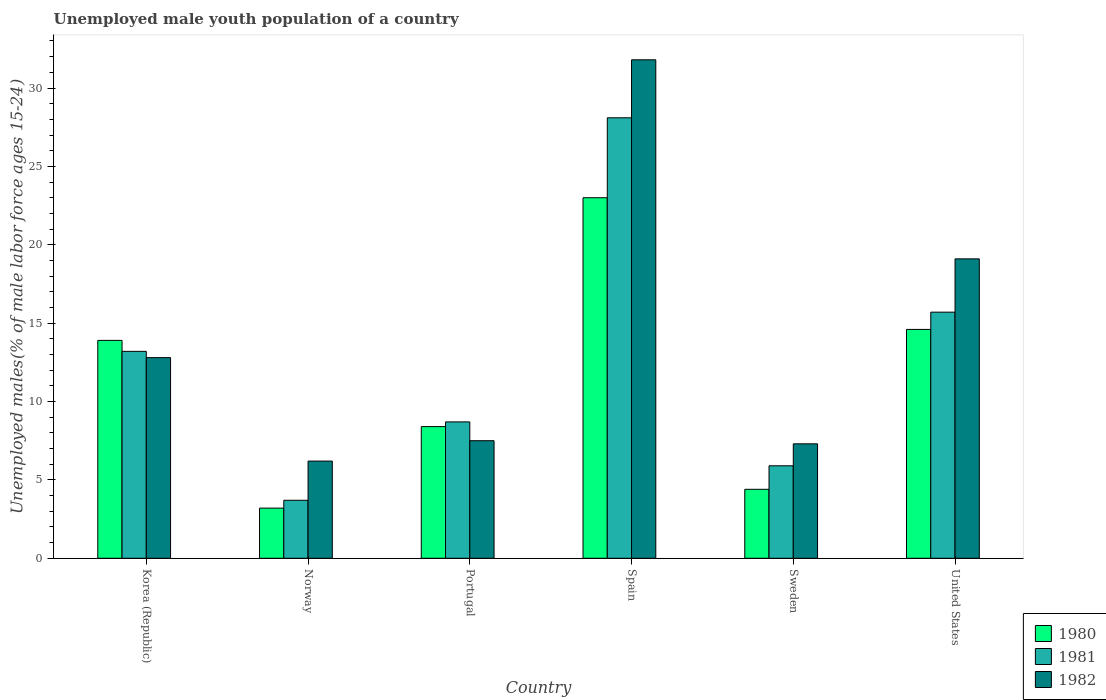Are the number of bars per tick equal to the number of legend labels?
Offer a very short reply. Yes. In how many cases, is the number of bars for a given country not equal to the number of legend labels?
Give a very brief answer. 0. What is the percentage of unemployed male youth population in 1982 in Sweden?
Offer a terse response. 7.3. Across all countries, what is the minimum percentage of unemployed male youth population in 1981?
Your answer should be very brief. 3.7. In which country was the percentage of unemployed male youth population in 1982 minimum?
Give a very brief answer. Norway. What is the total percentage of unemployed male youth population in 1981 in the graph?
Ensure brevity in your answer.  75.3. What is the difference between the percentage of unemployed male youth population in 1980 in Spain and that in Sweden?
Give a very brief answer. 18.6. What is the difference between the percentage of unemployed male youth population in 1982 in Spain and the percentage of unemployed male youth population in 1980 in Norway?
Ensure brevity in your answer.  28.6. What is the average percentage of unemployed male youth population in 1980 per country?
Your response must be concise. 11.25. What is the difference between the percentage of unemployed male youth population of/in 1982 and percentage of unemployed male youth population of/in 1981 in Portugal?
Your answer should be very brief. -1.2. What is the ratio of the percentage of unemployed male youth population in 1982 in Korea (Republic) to that in Sweden?
Ensure brevity in your answer.  1.75. Is the difference between the percentage of unemployed male youth population in 1982 in Portugal and United States greater than the difference between the percentage of unemployed male youth population in 1981 in Portugal and United States?
Ensure brevity in your answer.  No. What is the difference between the highest and the second highest percentage of unemployed male youth population in 1982?
Give a very brief answer. 6.3. What is the difference between the highest and the lowest percentage of unemployed male youth population in 1981?
Provide a succinct answer. 24.4. Is the sum of the percentage of unemployed male youth population in 1981 in Spain and United States greater than the maximum percentage of unemployed male youth population in 1982 across all countries?
Make the answer very short. Yes. How many countries are there in the graph?
Provide a short and direct response. 6. Are the values on the major ticks of Y-axis written in scientific E-notation?
Your answer should be very brief. No. Does the graph contain any zero values?
Provide a succinct answer. No. How many legend labels are there?
Provide a succinct answer. 3. How are the legend labels stacked?
Offer a terse response. Vertical. What is the title of the graph?
Your response must be concise. Unemployed male youth population of a country. What is the label or title of the X-axis?
Keep it short and to the point. Country. What is the label or title of the Y-axis?
Offer a terse response. Unemployed males(% of male labor force ages 15-24). What is the Unemployed males(% of male labor force ages 15-24) in 1980 in Korea (Republic)?
Keep it short and to the point. 13.9. What is the Unemployed males(% of male labor force ages 15-24) in 1981 in Korea (Republic)?
Ensure brevity in your answer.  13.2. What is the Unemployed males(% of male labor force ages 15-24) in 1982 in Korea (Republic)?
Your response must be concise. 12.8. What is the Unemployed males(% of male labor force ages 15-24) of 1980 in Norway?
Your answer should be very brief. 3.2. What is the Unemployed males(% of male labor force ages 15-24) in 1981 in Norway?
Offer a very short reply. 3.7. What is the Unemployed males(% of male labor force ages 15-24) in 1982 in Norway?
Ensure brevity in your answer.  6.2. What is the Unemployed males(% of male labor force ages 15-24) of 1980 in Portugal?
Provide a succinct answer. 8.4. What is the Unemployed males(% of male labor force ages 15-24) in 1981 in Portugal?
Your response must be concise. 8.7. What is the Unemployed males(% of male labor force ages 15-24) in 1981 in Spain?
Provide a short and direct response. 28.1. What is the Unemployed males(% of male labor force ages 15-24) of 1982 in Spain?
Provide a short and direct response. 31.8. What is the Unemployed males(% of male labor force ages 15-24) of 1980 in Sweden?
Offer a very short reply. 4.4. What is the Unemployed males(% of male labor force ages 15-24) in 1981 in Sweden?
Make the answer very short. 5.9. What is the Unemployed males(% of male labor force ages 15-24) in 1982 in Sweden?
Provide a succinct answer. 7.3. What is the Unemployed males(% of male labor force ages 15-24) of 1980 in United States?
Make the answer very short. 14.6. What is the Unemployed males(% of male labor force ages 15-24) of 1981 in United States?
Your response must be concise. 15.7. What is the Unemployed males(% of male labor force ages 15-24) of 1982 in United States?
Your response must be concise. 19.1. Across all countries, what is the maximum Unemployed males(% of male labor force ages 15-24) in 1981?
Provide a short and direct response. 28.1. Across all countries, what is the maximum Unemployed males(% of male labor force ages 15-24) in 1982?
Give a very brief answer. 31.8. Across all countries, what is the minimum Unemployed males(% of male labor force ages 15-24) of 1980?
Keep it short and to the point. 3.2. Across all countries, what is the minimum Unemployed males(% of male labor force ages 15-24) of 1981?
Make the answer very short. 3.7. Across all countries, what is the minimum Unemployed males(% of male labor force ages 15-24) of 1982?
Your answer should be very brief. 6.2. What is the total Unemployed males(% of male labor force ages 15-24) in 1980 in the graph?
Your answer should be very brief. 67.5. What is the total Unemployed males(% of male labor force ages 15-24) of 1981 in the graph?
Keep it short and to the point. 75.3. What is the total Unemployed males(% of male labor force ages 15-24) in 1982 in the graph?
Ensure brevity in your answer.  84.7. What is the difference between the Unemployed males(% of male labor force ages 15-24) of 1980 in Korea (Republic) and that in Norway?
Your answer should be very brief. 10.7. What is the difference between the Unemployed males(% of male labor force ages 15-24) in 1981 in Korea (Republic) and that in Norway?
Provide a succinct answer. 9.5. What is the difference between the Unemployed males(% of male labor force ages 15-24) in 1981 in Korea (Republic) and that in Portugal?
Your answer should be compact. 4.5. What is the difference between the Unemployed males(% of male labor force ages 15-24) in 1982 in Korea (Republic) and that in Portugal?
Offer a terse response. 5.3. What is the difference between the Unemployed males(% of male labor force ages 15-24) of 1980 in Korea (Republic) and that in Spain?
Make the answer very short. -9.1. What is the difference between the Unemployed males(% of male labor force ages 15-24) of 1981 in Korea (Republic) and that in Spain?
Give a very brief answer. -14.9. What is the difference between the Unemployed males(% of male labor force ages 15-24) in 1982 in Korea (Republic) and that in Spain?
Keep it short and to the point. -19. What is the difference between the Unemployed males(% of male labor force ages 15-24) in 1982 in Korea (Republic) and that in Sweden?
Give a very brief answer. 5.5. What is the difference between the Unemployed males(% of male labor force ages 15-24) of 1981 in Korea (Republic) and that in United States?
Provide a short and direct response. -2.5. What is the difference between the Unemployed males(% of male labor force ages 15-24) in 1982 in Norway and that in Portugal?
Provide a short and direct response. -1.3. What is the difference between the Unemployed males(% of male labor force ages 15-24) of 1980 in Norway and that in Spain?
Give a very brief answer. -19.8. What is the difference between the Unemployed males(% of male labor force ages 15-24) of 1981 in Norway and that in Spain?
Your answer should be very brief. -24.4. What is the difference between the Unemployed males(% of male labor force ages 15-24) in 1982 in Norway and that in Spain?
Your answer should be compact. -25.6. What is the difference between the Unemployed males(% of male labor force ages 15-24) of 1980 in Norway and that in Sweden?
Give a very brief answer. -1.2. What is the difference between the Unemployed males(% of male labor force ages 15-24) in 1982 in Norway and that in Sweden?
Ensure brevity in your answer.  -1.1. What is the difference between the Unemployed males(% of male labor force ages 15-24) in 1980 in Norway and that in United States?
Give a very brief answer. -11.4. What is the difference between the Unemployed males(% of male labor force ages 15-24) of 1982 in Norway and that in United States?
Offer a terse response. -12.9. What is the difference between the Unemployed males(% of male labor force ages 15-24) in 1980 in Portugal and that in Spain?
Ensure brevity in your answer.  -14.6. What is the difference between the Unemployed males(% of male labor force ages 15-24) of 1981 in Portugal and that in Spain?
Offer a terse response. -19.4. What is the difference between the Unemployed males(% of male labor force ages 15-24) of 1982 in Portugal and that in Spain?
Your answer should be compact. -24.3. What is the difference between the Unemployed males(% of male labor force ages 15-24) in 1980 in Portugal and that in Sweden?
Make the answer very short. 4. What is the difference between the Unemployed males(% of male labor force ages 15-24) of 1982 in Portugal and that in Sweden?
Your answer should be very brief. 0.2. What is the difference between the Unemployed males(% of male labor force ages 15-24) of 1981 in Portugal and that in United States?
Your answer should be compact. -7. What is the difference between the Unemployed males(% of male labor force ages 15-24) of 1982 in Portugal and that in United States?
Make the answer very short. -11.6. What is the difference between the Unemployed males(% of male labor force ages 15-24) in 1981 in Spain and that in Sweden?
Your response must be concise. 22.2. What is the difference between the Unemployed males(% of male labor force ages 15-24) in 1982 in Spain and that in United States?
Give a very brief answer. 12.7. What is the difference between the Unemployed males(% of male labor force ages 15-24) of 1981 in Sweden and that in United States?
Provide a short and direct response. -9.8. What is the difference between the Unemployed males(% of male labor force ages 15-24) of 1980 in Korea (Republic) and the Unemployed males(% of male labor force ages 15-24) of 1982 in Norway?
Ensure brevity in your answer.  7.7. What is the difference between the Unemployed males(% of male labor force ages 15-24) in 1980 in Korea (Republic) and the Unemployed males(% of male labor force ages 15-24) in 1981 in Portugal?
Your response must be concise. 5.2. What is the difference between the Unemployed males(% of male labor force ages 15-24) of 1981 in Korea (Republic) and the Unemployed males(% of male labor force ages 15-24) of 1982 in Portugal?
Your answer should be compact. 5.7. What is the difference between the Unemployed males(% of male labor force ages 15-24) in 1980 in Korea (Republic) and the Unemployed males(% of male labor force ages 15-24) in 1981 in Spain?
Provide a short and direct response. -14.2. What is the difference between the Unemployed males(% of male labor force ages 15-24) of 1980 in Korea (Republic) and the Unemployed males(% of male labor force ages 15-24) of 1982 in Spain?
Make the answer very short. -17.9. What is the difference between the Unemployed males(% of male labor force ages 15-24) in 1981 in Korea (Republic) and the Unemployed males(% of male labor force ages 15-24) in 1982 in Spain?
Offer a terse response. -18.6. What is the difference between the Unemployed males(% of male labor force ages 15-24) in 1980 in Korea (Republic) and the Unemployed males(% of male labor force ages 15-24) in 1981 in Sweden?
Your answer should be compact. 8. What is the difference between the Unemployed males(% of male labor force ages 15-24) in 1980 in Korea (Republic) and the Unemployed males(% of male labor force ages 15-24) in 1981 in United States?
Provide a succinct answer. -1.8. What is the difference between the Unemployed males(% of male labor force ages 15-24) in 1981 in Korea (Republic) and the Unemployed males(% of male labor force ages 15-24) in 1982 in United States?
Offer a terse response. -5.9. What is the difference between the Unemployed males(% of male labor force ages 15-24) of 1980 in Norway and the Unemployed males(% of male labor force ages 15-24) of 1981 in Portugal?
Your answer should be very brief. -5.5. What is the difference between the Unemployed males(% of male labor force ages 15-24) of 1980 in Norway and the Unemployed males(% of male labor force ages 15-24) of 1981 in Spain?
Your answer should be very brief. -24.9. What is the difference between the Unemployed males(% of male labor force ages 15-24) of 1980 in Norway and the Unemployed males(% of male labor force ages 15-24) of 1982 in Spain?
Offer a very short reply. -28.6. What is the difference between the Unemployed males(% of male labor force ages 15-24) of 1981 in Norway and the Unemployed males(% of male labor force ages 15-24) of 1982 in Spain?
Your response must be concise. -28.1. What is the difference between the Unemployed males(% of male labor force ages 15-24) in 1980 in Norway and the Unemployed males(% of male labor force ages 15-24) in 1982 in Sweden?
Give a very brief answer. -4.1. What is the difference between the Unemployed males(% of male labor force ages 15-24) of 1981 in Norway and the Unemployed males(% of male labor force ages 15-24) of 1982 in Sweden?
Give a very brief answer. -3.6. What is the difference between the Unemployed males(% of male labor force ages 15-24) of 1980 in Norway and the Unemployed males(% of male labor force ages 15-24) of 1982 in United States?
Give a very brief answer. -15.9. What is the difference between the Unemployed males(% of male labor force ages 15-24) in 1981 in Norway and the Unemployed males(% of male labor force ages 15-24) in 1982 in United States?
Keep it short and to the point. -15.4. What is the difference between the Unemployed males(% of male labor force ages 15-24) in 1980 in Portugal and the Unemployed males(% of male labor force ages 15-24) in 1981 in Spain?
Your response must be concise. -19.7. What is the difference between the Unemployed males(% of male labor force ages 15-24) of 1980 in Portugal and the Unemployed males(% of male labor force ages 15-24) of 1982 in Spain?
Keep it short and to the point. -23.4. What is the difference between the Unemployed males(% of male labor force ages 15-24) of 1981 in Portugal and the Unemployed males(% of male labor force ages 15-24) of 1982 in Spain?
Provide a succinct answer. -23.1. What is the difference between the Unemployed males(% of male labor force ages 15-24) in 1980 in Portugal and the Unemployed males(% of male labor force ages 15-24) in 1981 in Sweden?
Ensure brevity in your answer.  2.5. What is the difference between the Unemployed males(% of male labor force ages 15-24) of 1980 in Portugal and the Unemployed males(% of male labor force ages 15-24) of 1982 in Sweden?
Offer a very short reply. 1.1. What is the difference between the Unemployed males(% of male labor force ages 15-24) of 1981 in Portugal and the Unemployed males(% of male labor force ages 15-24) of 1982 in Sweden?
Make the answer very short. 1.4. What is the difference between the Unemployed males(% of male labor force ages 15-24) in 1980 in Portugal and the Unemployed males(% of male labor force ages 15-24) in 1981 in United States?
Give a very brief answer. -7.3. What is the difference between the Unemployed males(% of male labor force ages 15-24) of 1980 in Spain and the Unemployed males(% of male labor force ages 15-24) of 1981 in Sweden?
Keep it short and to the point. 17.1. What is the difference between the Unemployed males(% of male labor force ages 15-24) in 1981 in Spain and the Unemployed males(% of male labor force ages 15-24) in 1982 in Sweden?
Your answer should be compact. 20.8. What is the difference between the Unemployed males(% of male labor force ages 15-24) of 1980 in Spain and the Unemployed males(% of male labor force ages 15-24) of 1982 in United States?
Your response must be concise. 3.9. What is the difference between the Unemployed males(% of male labor force ages 15-24) in 1980 in Sweden and the Unemployed males(% of male labor force ages 15-24) in 1982 in United States?
Offer a very short reply. -14.7. What is the difference between the Unemployed males(% of male labor force ages 15-24) in 1981 in Sweden and the Unemployed males(% of male labor force ages 15-24) in 1982 in United States?
Ensure brevity in your answer.  -13.2. What is the average Unemployed males(% of male labor force ages 15-24) in 1980 per country?
Provide a succinct answer. 11.25. What is the average Unemployed males(% of male labor force ages 15-24) of 1981 per country?
Ensure brevity in your answer.  12.55. What is the average Unemployed males(% of male labor force ages 15-24) in 1982 per country?
Provide a short and direct response. 14.12. What is the difference between the Unemployed males(% of male labor force ages 15-24) of 1980 and Unemployed males(% of male labor force ages 15-24) of 1982 in Korea (Republic)?
Your response must be concise. 1.1. What is the difference between the Unemployed males(% of male labor force ages 15-24) of 1980 and Unemployed males(% of male labor force ages 15-24) of 1981 in Norway?
Your response must be concise. -0.5. What is the difference between the Unemployed males(% of male labor force ages 15-24) of 1980 and Unemployed males(% of male labor force ages 15-24) of 1981 in Portugal?
Offer a very short reply. -0.3. What is the difference between the Unemployed males(% of male labor force ages 15-24) in 1980 and Unemployed males(% of male labor force ages 15-24) in 1982 in Portugal?
Your response must be concise. 0.9. What is the difference between the Unemployed males(% of male labor force ages 15-24) in 1980 and Unemployed males(% of male labor force ages 15-24) in 1981 in Spain?
Your answer should be very brief. -5.1. What is the difference between the Unemployed males(% of male labor force ages 15-24) of 1980 and Unemployed males(% of male labor force ages 15-24) of 1982 in Spain?
Provide a succinct answer. -8.8. What is the difference between the Unemployed males(% of male labor force ages 15-24) in 1980 and Unemployed males(% of male labor force ages 15-24) in 1981 in Sweden?
Keep it short and to the point. -1.5. What is the difference between the Unemployed males(% of male labor force ages 15-24) of 1980 and Unemployed males(% of male labor force ages 15-24) of 1982 in Sweden?
Offer a very short reply. -2.9. What is the difference between the Unemployed males(% of male labor force ages 15-24) in 1981 and Unemployed males(% of male labor force ages 15-24) in 1982 in Sweden?
Make the answer very short. -1.4. What is the difference between the Unemployed males(% of male labor force ages 15-24) in 1980 and Unemployed males(% of male labor force ages 15-24) in 1981 in United States?
Give a very brief answer. -1.1. What is the difference between the Unemployed males(% of male labor force ages 15-24) in 1981 and Unemployed males(% of male labor force ages 15-24) in 1982 in United States?
Your answer should be very brief. -3.4. What is the ratio of the Unemployed males(% of male labor force ages 15-24) of 1980 in Korea (Republic) to that in Norway?
Your response must be concise. 4.34. What is the ratio of the Unemployed males(% of male labor force ages 15-24) of 1981 in Korea (Republic) to that in Norway?
Your response must be concise. 3.57. What is the ratio of the Unemployed males(% of male labor force ages 15-24) of 1982 in Korea (Republic) to that in Norway?
Offer a very short reply. 2.06. What is the ratio of the Unemployed males(% of male labor force ages 15-24) in 1980 in Korea (Republic) to that in Portugal?
Provide a short and direct response. 1.65. What is the ratio of the Unemployed males(% of male labor force ages 15-24) in 1981 in Korea (Republic) to that in Portugal?
Make the answer very short. 1.52. What is the ratio of the Unemployed males(% of male labor force ages 15-24) in 1982 in Korea (Republic) to that in Portugal?
Your response must be concise. 1.71. What is the ratio of the Unemployed males(% of male labor force ages 15-24) in 1980 in Korea (Republic) to that in Spain?
Keep it short and to the point. 0.6. What is the ratio of the Unemployed males(% of male labor force ages 15-24) of 1981 in Korea (Republic) to that in Spain?
Ensure brevity in your answer.  0.47. What is the ratio of the Unemployed males(% of male labor force ages 15-24) in 1982 in Korea (Republic) to that in Spain?
Your answer should be compact. 0.4. What is the ratio of the Unemployed males(% of male labor force ages 15-24) of 1980 in Korea (Republic) to that in Sweden?
Give a very brief answer. 3.16. What is the ratio of the Unemployed males(% of male labor force ages 15-24) of 1981 in Korea (Republic) to that in Sweden?
Provide a short and direct response. 2.24. What is the ratio of the Unemployed males(% of male labor force ages 15-24) in 1982 in Korea (Republic) to that in Sweden?
Ensure brevity in your answer.  1.75. What is the ratio of the Unemployed males(% of male labor force ages 15-24) of 1980 in Korea (Republic) to that in United States?
Provide a short and direct response. 0.95. What is the ratio of the Unemployed males(% of male labor force ages 15-24) of 1981 in Korea (Republic) to that in United States?
Offer a very short reply. 0.84. What is the ratio of the Unemployed males(% of male labor force ages 15-24) in 1982 in Korea (Republic) to that in United States?
Make the answer very short. 0.67. What is the ratio of the Unemployed males(% of male labor force ages 15-24) of 1980 in Norway to that in Portugal?
Provide a succinct answer. 0.38. What is the ratio of the Unemployed males(% of male labor force ages 15-24) of 1981 in Norway to that in Portugal?
Offer a terse response. 0.43. What is the ratio of the Unemployed males(% of male labor force ages 15-24) of 1982 in Norway to that in Portugal?
Offer a terse response. 0.83. What is the ratio of the Unemployed males(% of male labor force ages 15-24) of 1980 in Norway to that in Spain?
Your answer should be compact. 0.14. What is the ratio of the Unemployed males(% of male labor force ages 15-24) of 1981 in Norway to that in Spain?
Your answer should be compact. 0.13. What is the ratio of the Unemployed males(% of male labor force ages 15-24) of 1982 in Norway to that in Spain?
Make the answer very short. 0.2. What is the ratio of the Unemployed males(% of male labor force ages 15-24) in 1980 in Norway to that in Sweden?
Ensure brevity in your answer.  0.73. What is the ratio of the Unemployed males(% of male labor force ages 15-24) in 1981 in Norway to that in Sweden?
Offer a terse response. 0.63. What is the ratio of the Unemployed males(% of male labor force ages 15-24) of 1982 in Norway to that in Sweden?
Your answer should be very brief. 0.85. What is the ratio of the Unemployed males(% of male labor force ages 15-24) in 1980 in Norway to that in United States?
Provide a succinct answer. 0.22. What is the ratio of the Unemployed males(% of male labor force ages 15-24) in 1981 in Norway to that in United States?
Your answer should be very brief. 0.24. What is the ratio of the Unemployed males(% of male labor force ages 15-24) of 1982 in Norway to that in United States?
Your answer should be compact. 0.32. What is the ratio of the Unemployed males(% of male labor force ages 15-24) of 1980 in Portugal to that in Spain?
Your response must be concise. 0.37. What is the ratio of the Unemployed males(% of male labor force ages 15-24) of 1981 in Portugal to that in Spain?
Your response must be concise. 0.31. What is the ratio of the Unemployed males(% of male labor force ages 15-24) in 1982 in Portugal to that in Spain?
Provide a short and direct response. 0.24. What is the ratio of the Unemployed males(% of male labor force ages 15-24) in 1980 in Portugal to that in Sweden?
Give a very brief answer. 1.91. What is the ratio of the Unemployed males(% of male labor force ages 15-24) in 1981 in Portugal to that in Sweden?
Provide a short and direct response. 1.47. What is the ratio of the Unemployed males(% of male labor force ages 15-24) in 1982 in Portugal to that in Sweden?
Ensure brevity in your answer.  1.03. What is the ratio of the Unemployed males(% of male labor force ages 15-24) in 1980 in Portugal to that in United States?
Provide a short and direct response. 0.58. What is the ratio of the Unemployed males(% of male labor force ages 15-24) in 1981 in Portugal to that in United States?
Ensure brevity in your answer.  0.55. What is the ratio of the Unemployed males(% of male labor force ages 15-24) in 1982 in Portugal to that in United States?
Ensure brevity in your answer.  0.39. What is the ratio of the Unemployed males(% of male labor force ages 15-24) in 1980 in Spain to that in Sweden?
Offer a terse response. 5.23. What is the ratio of the Unemployed males(% of male labor force ages 15-24) of 1981 in Spain to that in Sweden?
Offer a terse response. 4.76. What is the ratio of the Unemployed males(% of male labor force ages 15-24) in 1982 in Spain to that in Sweden?
Offer a very short reply. 4.36. What is the ratio of the Unemployed males(% of male labor force ages 15-24) in 1980 in Spain to that in United States?
Keep it short and to the point. 1.58. What is the ratio of the Unemployed males(% of male labor force ages 15-24) of 1981 in Spain to that in United States?
Provide a short and direct response. 1.79. What is the ratio of the Unemployed males(% of male labor force ages 15-24) in 1982 in Spain to that in United States?
Make the answer very short. 1.66. What is the ratio of the Unemployed males(% of male labor force ages 15-24) in 1980 in Sweden to that in United States?
Keep it short and to the point. 0.3. What is the ratio of the Unemployed males(% of male labor force ages 15-24) of 1981 in Sweden to that in United States?
Your answer should be compact. 0.38. What is the ratio of the Unemployed males(% of male labor force ages 15-24) of 1982 in Sweden to that in United States?
Offer a terse response. 0.38. What is the difference between the highest and the second highest Unemployed males(% of male labor force ages 15-24) in 1980?
Make the answer very short. 8.4. What is the difference between the highest and the lowest Unemployed males(% of male labor force ages 15-24) of 1980?
Your answer should be compact. 19.8. What is the difference between the highest and the lowest Unemployed males(% of male labor force ages 15-24) of 1981?
Keep it short and to the point. 24.4. What is the difference between the highest and the lowest Unemployed males(% of male labor force ages 15-24) in 1982?
Your answer should be compact. 25.6. 